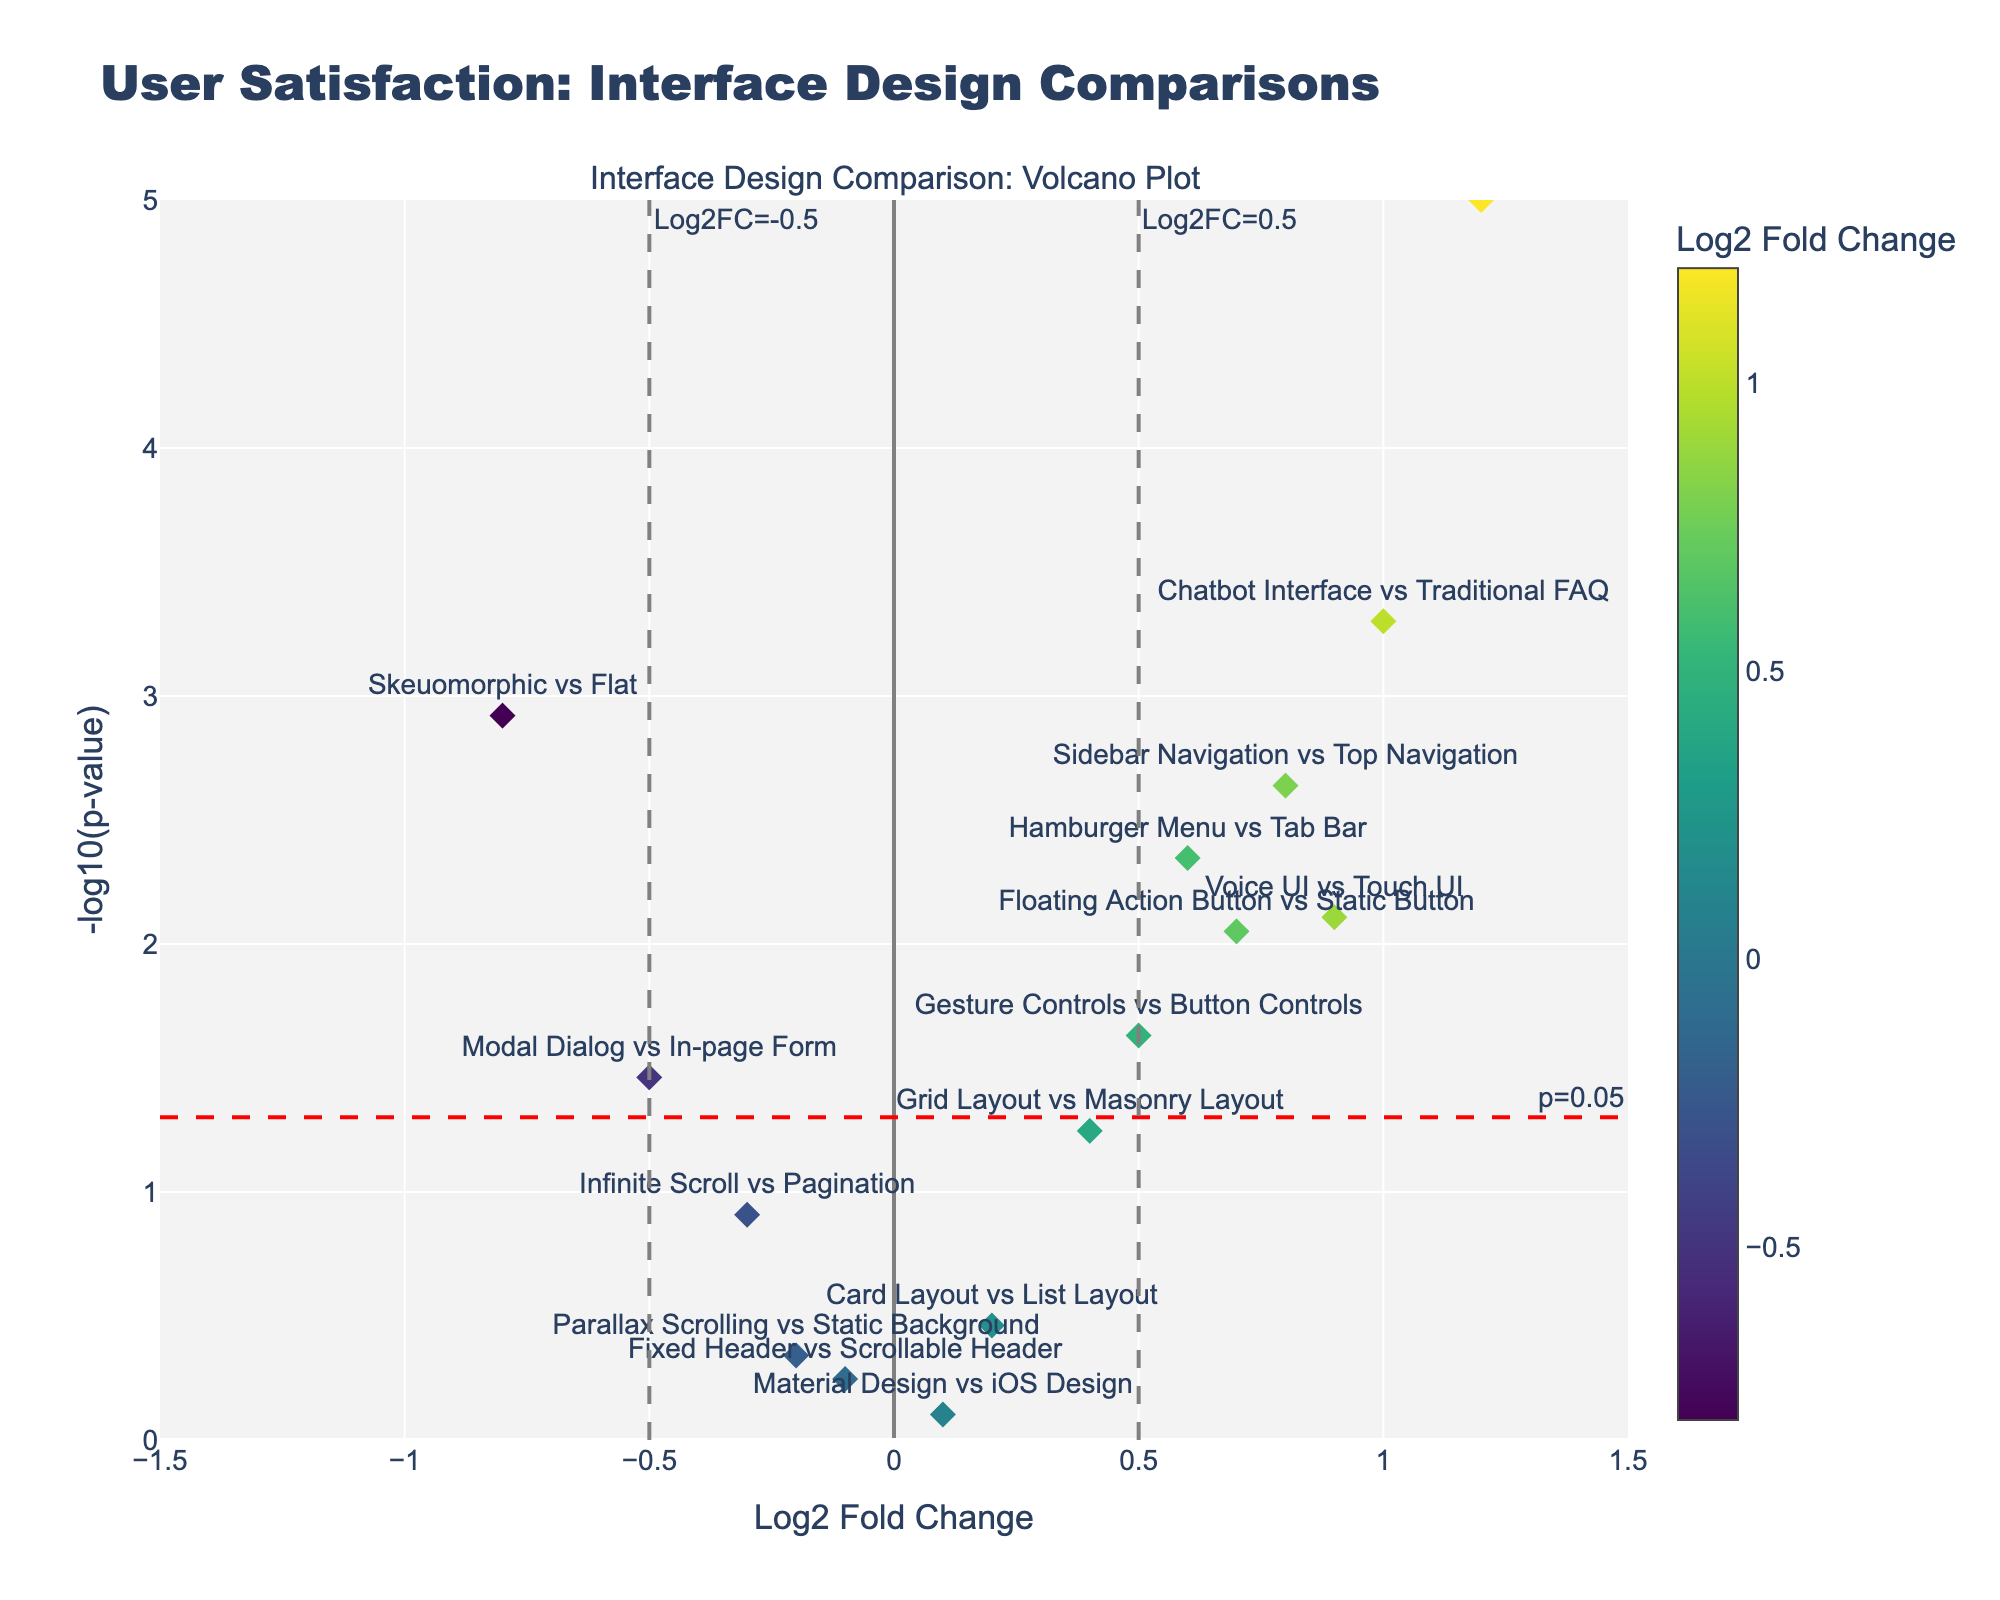What is the title of the figure? The title can be found at the top of the figure, and it summarizes the main content of the plot.
Answer: User Satisfaction: Interface Design Comparisons What does the x-axis represent? The x-axis title usually describes what data is being shown. In this case, the x-axis shows "Log2 Fold Change," which indicates the level of change in user satisfaction scores between interface designs.
Answer: Log2 Fold Change What is represented by the y-axis? The y-axis title typically clarifies the measurement plotted against the x-axis. Here, the y-axis illustrates "-log10(p-value)," indicating the statistical significance of changes in user satisfaction.
Answer: -log10(p-value) Which interface comparison has the highest statistical significance? The most statistically significant comparison will have the highest -log10(p-value). By checking the highest point on the y-axis, you can determine this interface.
Answer: Dark Mode vs Light Mode How many interface comparisons are statistically significant at the p=0.05 level? To determine if the interfaces are statistically significant at p=0.05, check data points above the red dashed line denoting -log10(0.05).
Answer: Seven Which interface comparison shows the largest positive user satisfaction increase? To find the largest positive user satisfaction increase, look for the data point furthest to the right on the x-axis.
Answer: Dark Mode vs Light Mode Which interface comparison has a user satisfaction score decrease but is not statistically significant? A decrease is indicated by a negative Log2 Fold Change and non-significance by a p-value above 0.05. Find points to the left of the zero line and below the red dashed line.
Answer: Infinite Scroll vs Pagination What is the log2 fold change for 'Hamburger Menu vs Tab Bar'? Check the position of the data point labeled 'Hamburger Menu vs Tab Bar' along the x-axis to read the Log2 Fold Change value directly.
Answer: 0.6 Compare the statistical significance of 'Sidebar Navigation vs Top Navigation' to 'Voice UI vs Touch UI'. Which one is more statistically significant? Compare their y-axis positions; the higher the point, the more statistically significant. 'Sidebar Navigation vs Top Navigation' is higher than 'Voice UI vs Touch UI'.
Answer: Sidebar Navigation vs Top Navigation What is the p-value for 'Card Layout vs List Layout'? The hover text for each data point shows detailed information. For 'Card Layout vs List Layout,' the p-value can be gleaned directly from this text.
Answer: 0.3456 